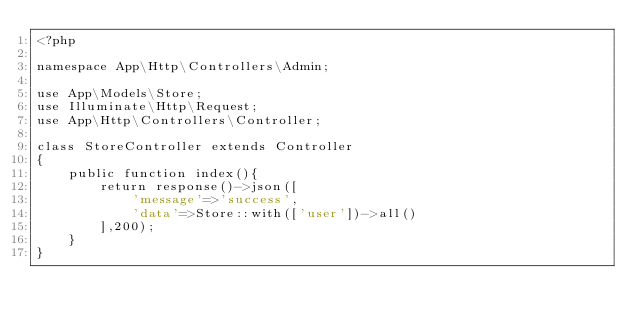<code> <loc_0><loc_0><loc_500><loc_500><_PHP_><?php

namespace App\Http\Controllers\Admin;

use App\Models\Store;
use Illuminate\Http\Request;
use App\Http\Controllers\Controller;

class StoreController extends Controller
{
    public function index(){
        return response()->json([
            'message'=>'success',
            'data'=>Store::with(['user'])->all()
        ],200);
    }
}
</code> 